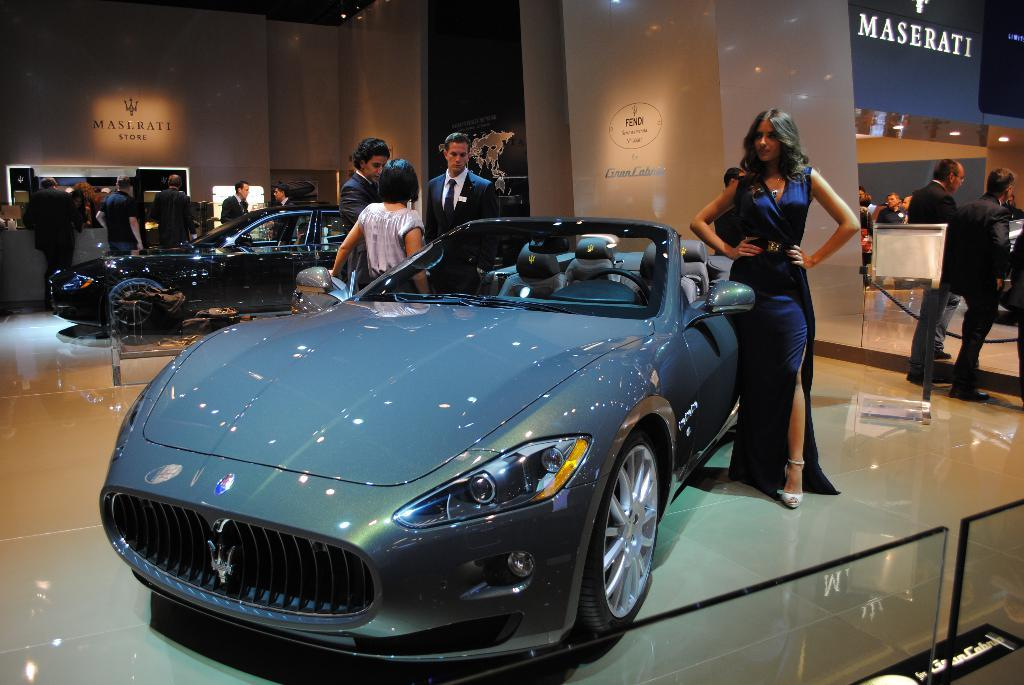What type of vehicles are present in the showroom? There are cars in the showroom. Can you describe the woman's position in the image? The woman is standing next to a car. Are there any other people visible in the image? Yes, there are people standing in the image. What type of yam is being used as fuel for the cars in the image? There is no yam or fuel mentioned in the image; it features a showroom with cars and people. 